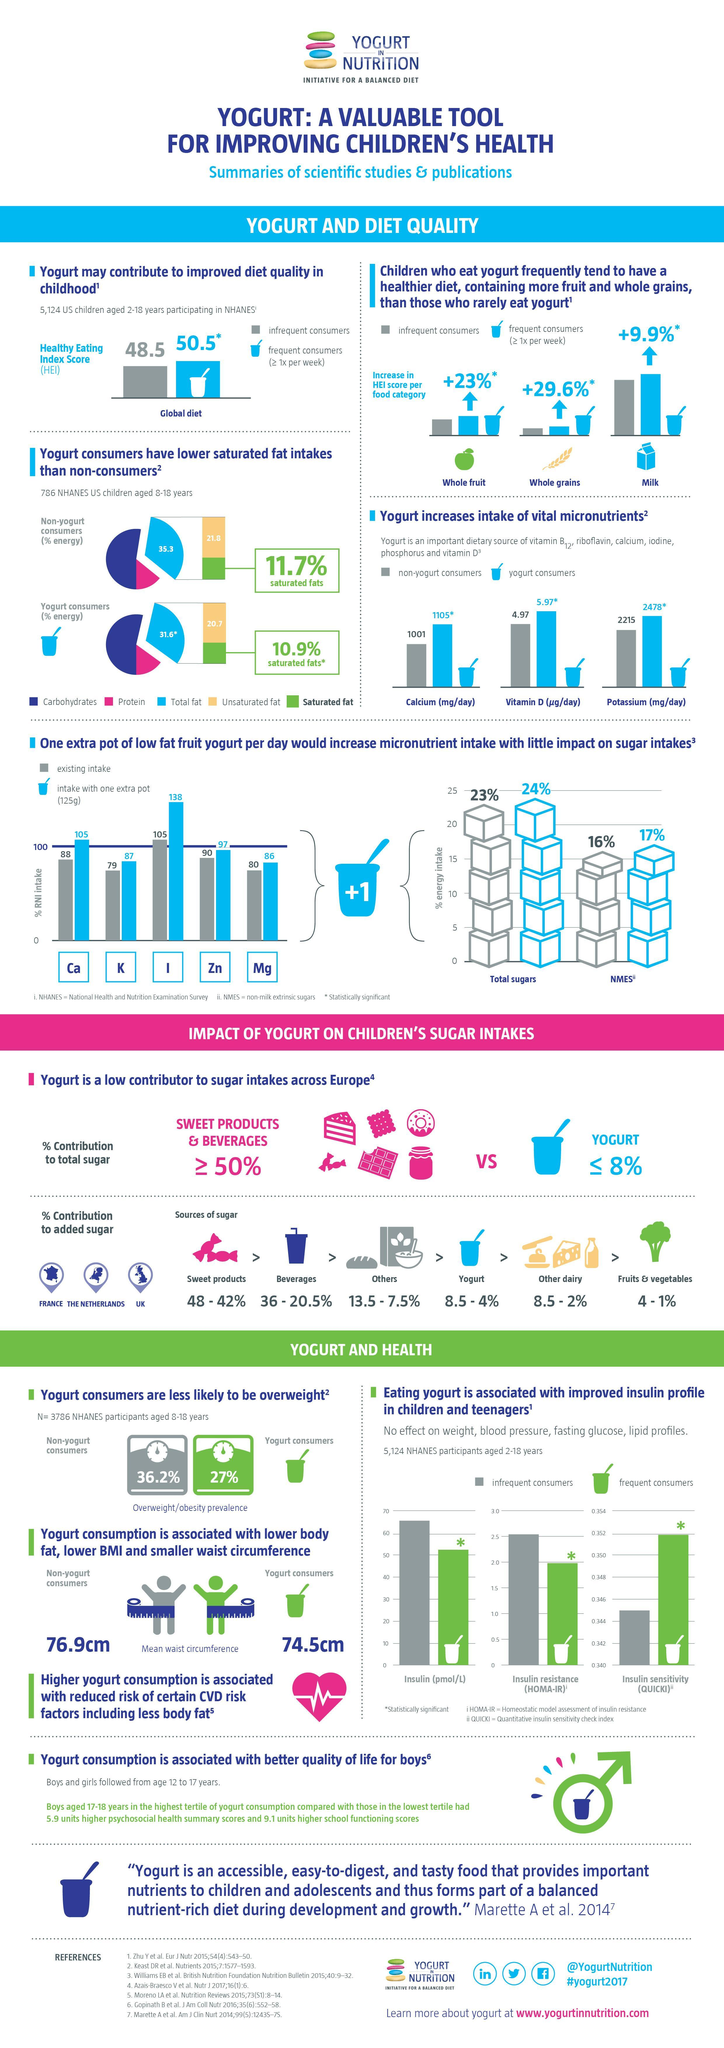What is the total percentage of carbohydrates and proteins consumed by yoghurt consumers?
Answer the question with a short phrase. 68.4% How much more percentage of unsaturated fats are consumed by non-yoghurt consumers in comparison to yoghurt consumers? 1.1% Which micronutrient is denoted by the letter K, Magnesium, Zinc, or Potassium? Potassium What is the total percentage of carbohydrates and proteins consumed by non-yoghurt consumers? 64.7% How much more percentage of saturated fats are consumed by non-yoghurt consumers in comparison to yoghurt consumers? 0.8% Which micronutrient shows the highest percentage of intake with an extra pot of yoghurt consumed, Calcium, Iodine, or Zinc? Iodine What is the percentage contribution of sugar from other diary sources? 8.5 - 2% What is the difference in the mean waist circumference of non-yoghurt and yoghurt consumers? 2.4 cm 